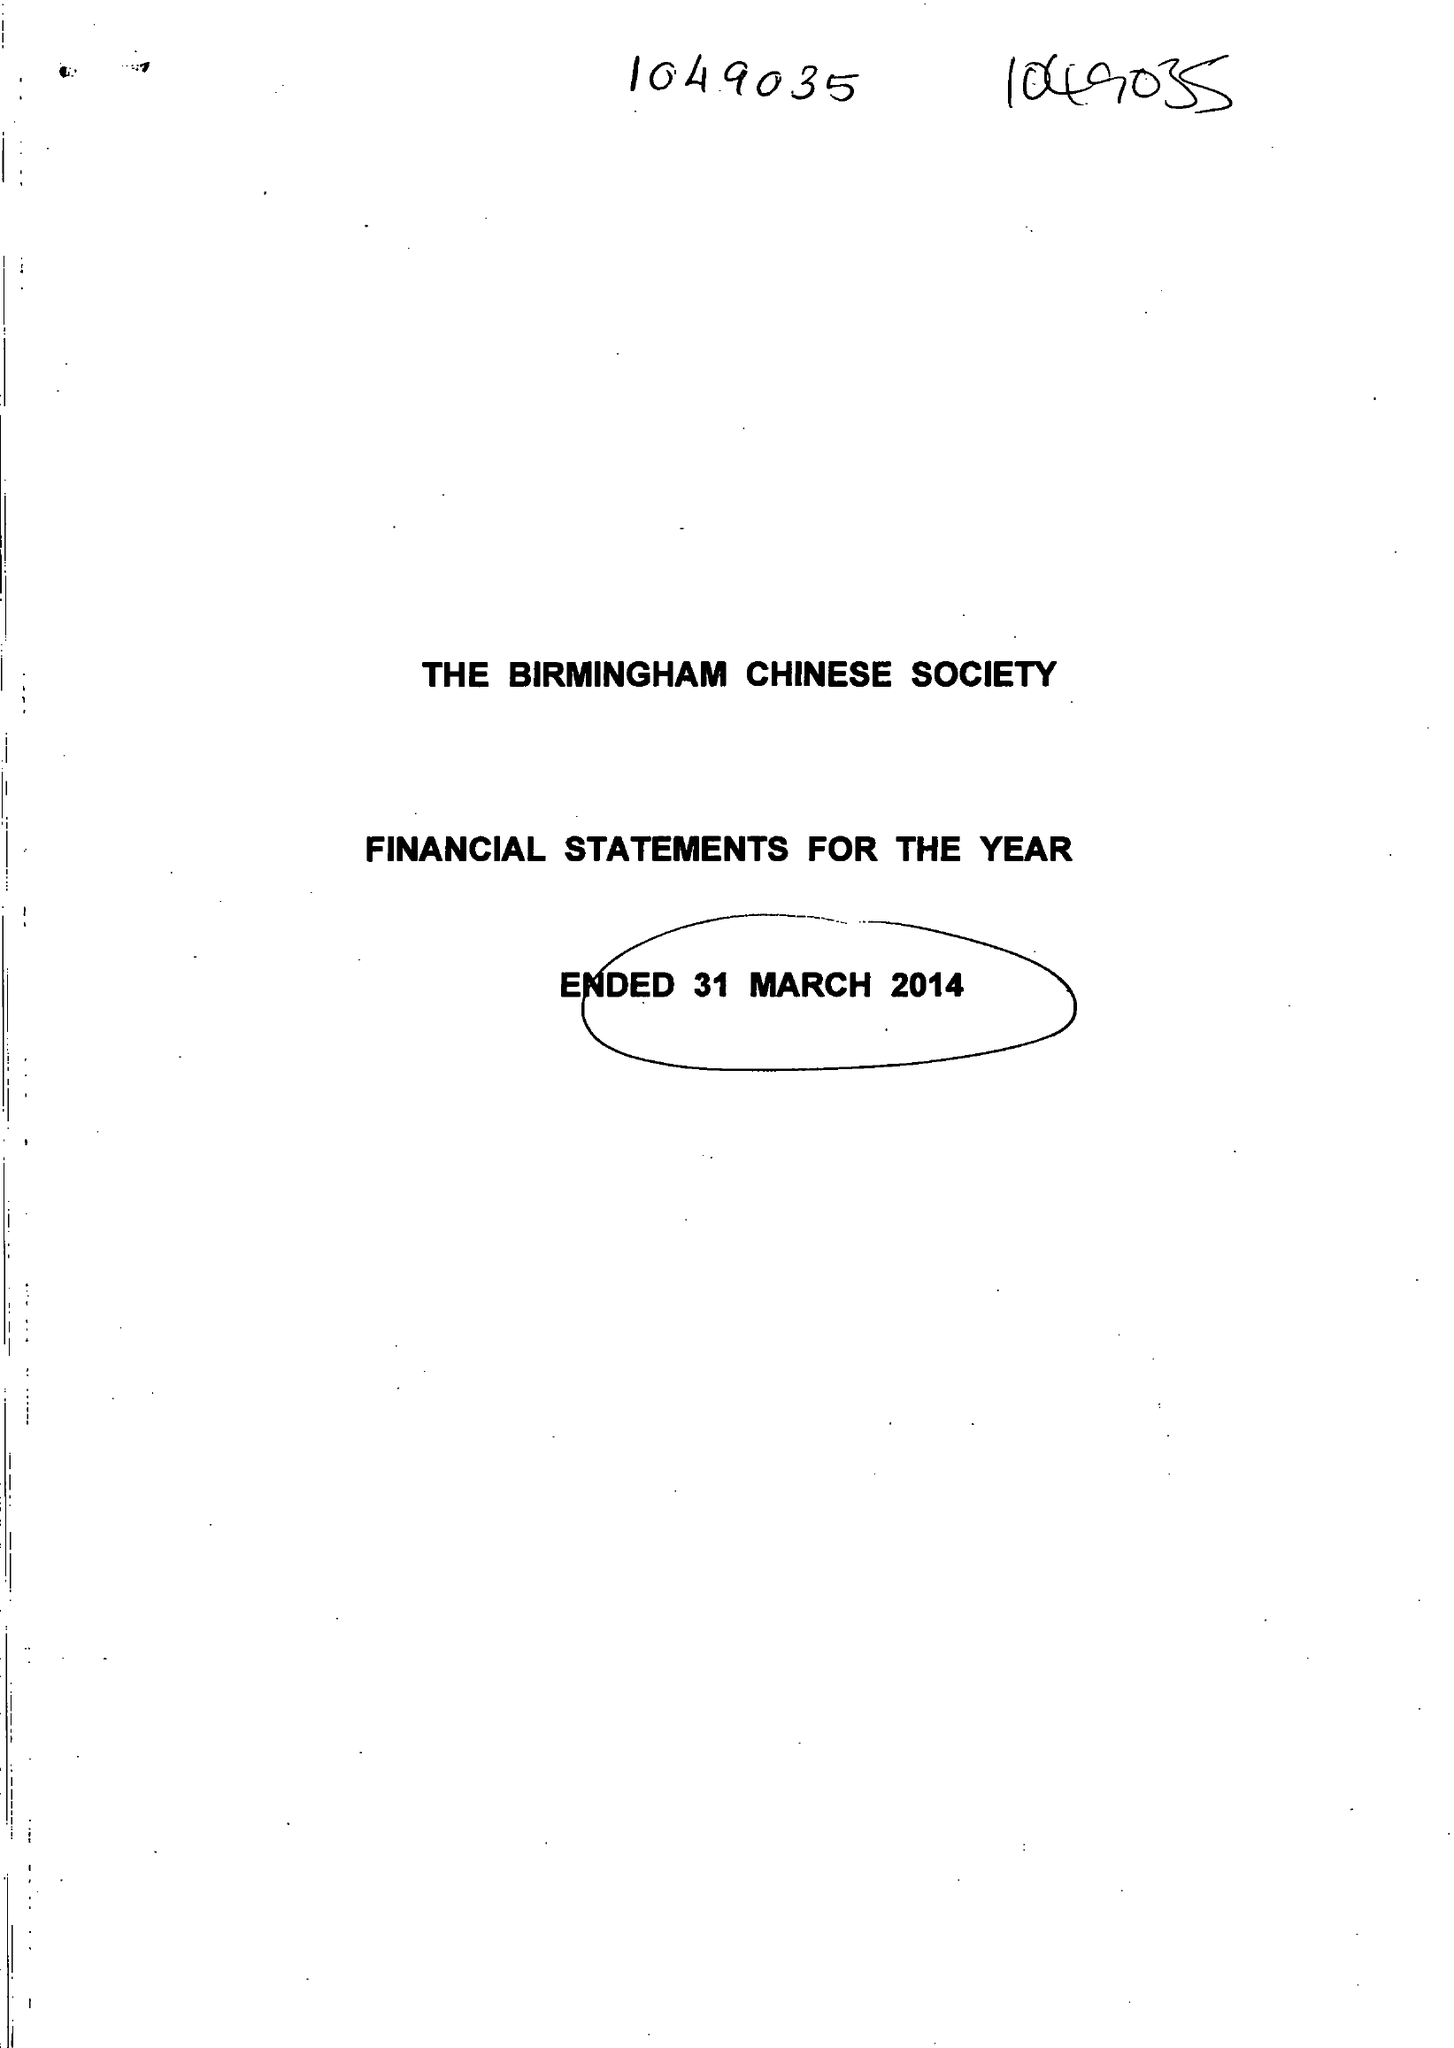What is the value for the address__post_town?
Answer the question using a single word or phrase. BIRMINGHAM 